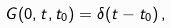Convert formula to latex. <formula><loc_0><loc_0><loc_500><loc_500>G ( 0 , t , t _ { 0 } ) = \delta ( t - t _ { 0 } ) \, ,</formula> 